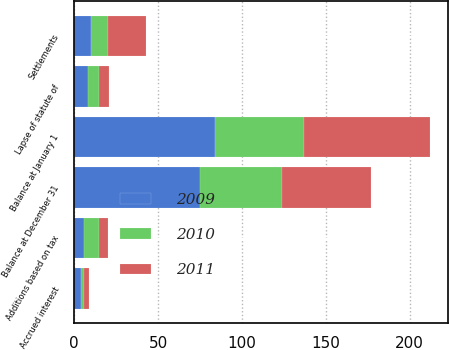Convert chart. <chart><loc_0><loc_0><loc_500><loc_500><stacked_bar_chart><ecel><fcel>Balance at January 1<fcel>Additions based on tax<fcel>Accrued interest<fcel>Settlements<fcel>Lapse of statute of<fcel>Balance at December 31<nl><fcel>2010<fcel>53<fcel>9<fcel>2<fcel>10<fcel>7<fcel>49<nl><fcel>2011<fcel>75<fcel>5<fcel>3<fcel>23<fcel>6<fcel>53<nl><fcel>2009<fcel>84<fcel>6<fcel>4<fcel>10<fcel>8<fcel>75<nl></chart> 